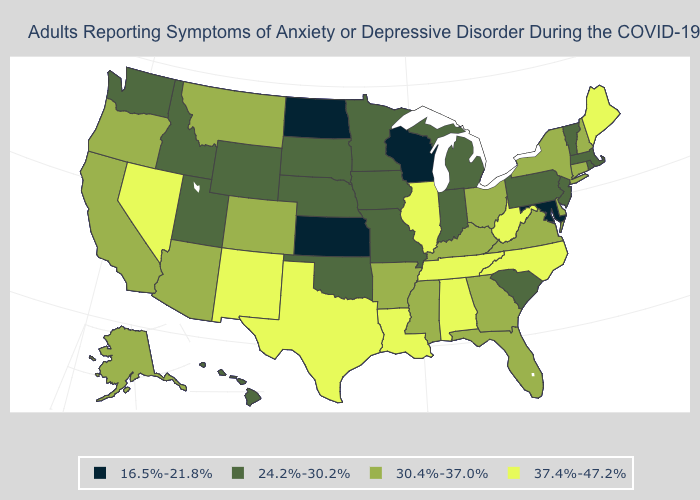What is the value of Maryland?
Concise answer only. 16.5%-21.8%. What is the value of North Dakota?
Write a very short answer. 16.5%-21.8%. Which states have the lowest value in the MidWest?
Give a very brief answer. Kansas, North Dakota, Wisconsin. Among the states that border Michigan , which have the lowest value?
Be succinct. Wisconsin. Does the first symbol in the legend represent the smallest category?
Answer briefly. Yes. Which states have the lowest value in the USA?
Write a very short answer. Kansas, Maryland, North Dakota, Wisconsin. Name the states that have a value in the range 30.4%-37.0%?
Short answer required. Alaska, Arizona, Arkansas, California, Colorado, Connecticut, Delaware, Florida, Georgia, Kentucky, Mississippi, Montana, New Hampshire, New York, Ohio, Oregon, Virginia. Does New Jersey have the same value as Alabama?
Write a very short answer. No. What is the lowest value in the West?
Write a very short answer. 24.2%-30.2%. Which states have the lowest value in the USA?
Quick response, please. Kansas, Maryland, North Dakota, Wisconsin. How many symbols are there in the legend?
Give a very brief answer. 4. Name the states that have a value in the range 30.4%-37.0%?
Be succinct. Alaska, Arizona, Arkansas, California, Colorado, Connecticut, Delaware, Florida, Georgia, Kentucky, Mississippi, Montana, New Hampshire, New York, Ohio, Oregon, Virginia. What is the value of Wyoming?
Answer briefly. 24.2%-30.2%. What is the highest value in states that border South Carolina?
Keep it brief. 37.4%-47.2%. Is the legend a continuous bar?
Give a very brief answer. No. 